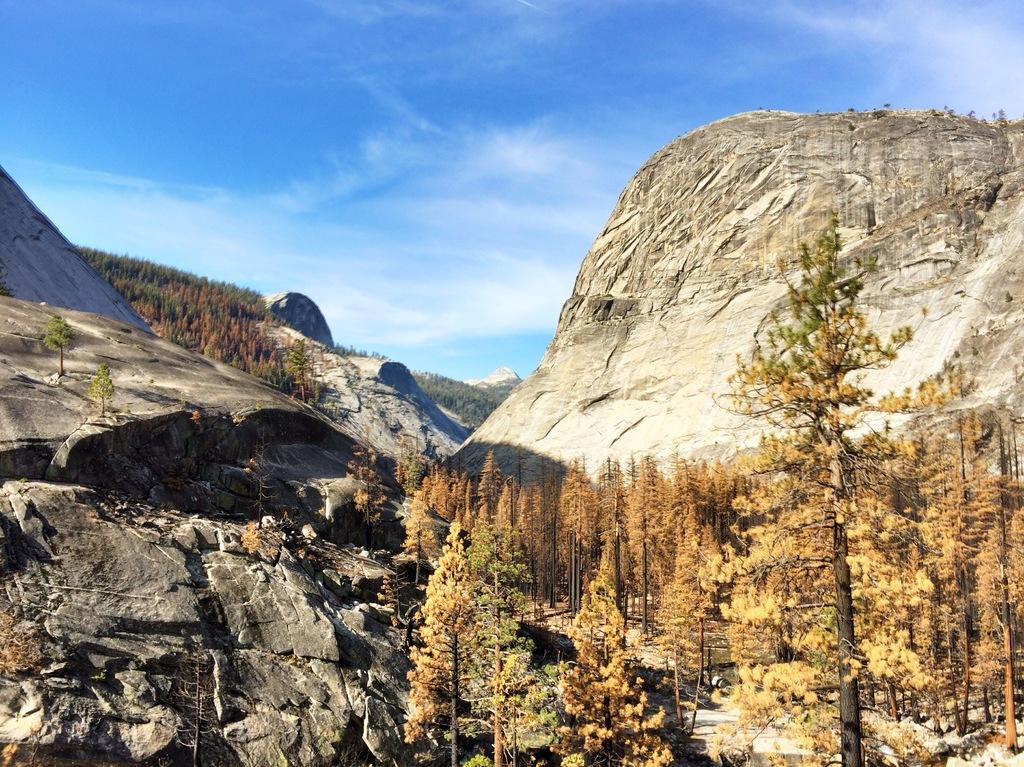What type of vegetation can be seen in the image? There are trees in the image. What else can be found on the ground in the image? There are rocks in the image. What is visible above the trees and rocks in the image? The sky is visible in the image. What can be seen in the sky in the image? Clouds are present in the sky. What type of lettuce is growing near the coast in the image? There is no lettuce or coast present in the image; it features trees, rocks, sky, and clouds. 